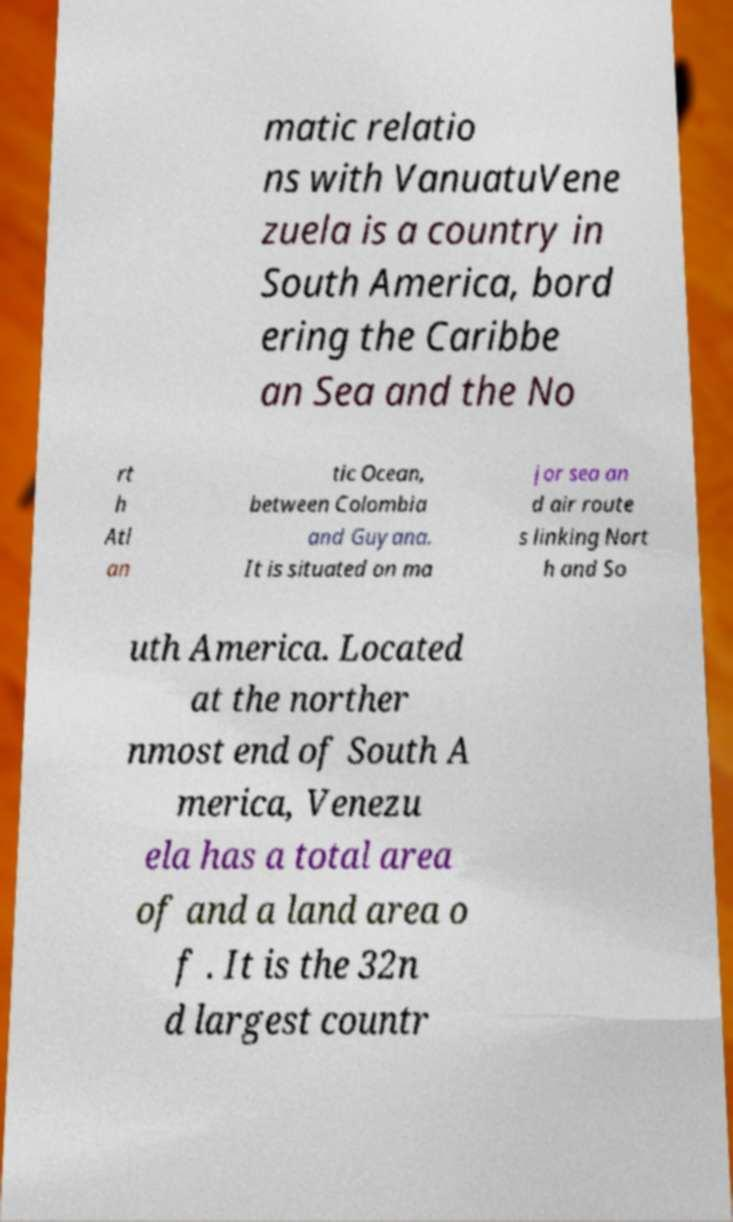Please identify and transcribe the text found in this image. matic relatio ns with VanuatuVene zuela is a country in South America, bord ering the Caribbe an Sea and the No rt h Atl an tic Ocean, between Colombia and Guyana. It is situated on ma jor sea an d air route s linking Nort h and So uth America. Located at the norther nmost end of South A merica, Venezu ela has a total area of and a land area o f . It is the 32n d largest countr 